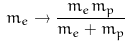Convert formula to latex. <formula><loc_0><loc_0><loc_500><loc_500>m _ { e } \rightarrow \frac { m _ { e } m _ { p } } { m _ { e } + m _ { p } }</formula> 